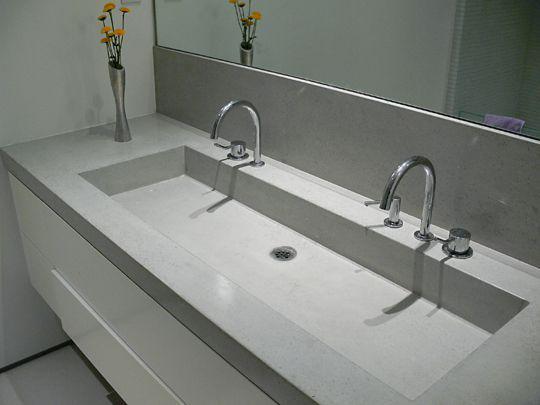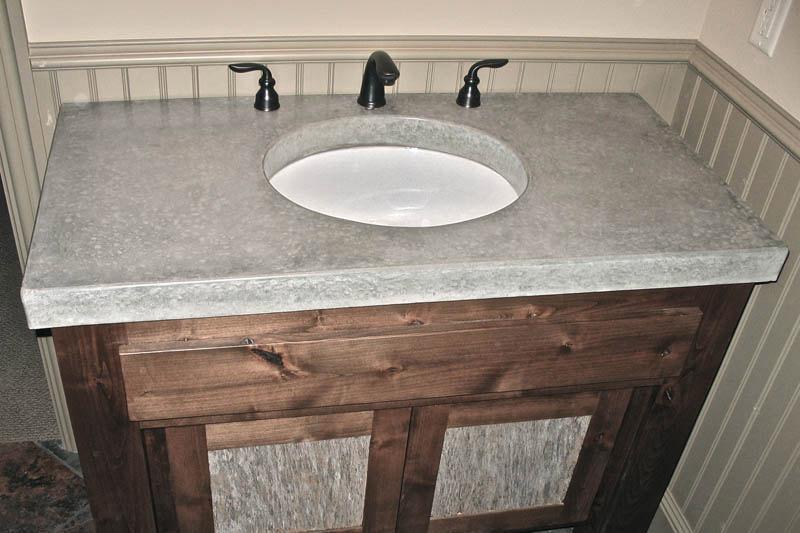The first image is the image on the left, the second image is the image on the right. Evaluate the accuracy of this statement regarding the images: "In one image the angled view of a wide bathroom sink with squared edges and two sets of faucets shows its inner triangular shape.". Is it true? Answer yes or no. No. The first image is the image on the left, the second image is the image on the right. For the images displayed, is the sentence "One vanity features a long gray rectangular trough, with nothing dividing it and with two faucet and spout sets that are not wall-mounted." factually correct? Answer yes or no. Yes. 